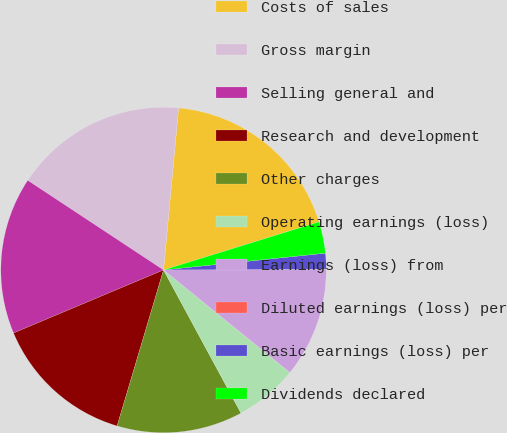Convert chart. <chart><loc_0><loc_0><loc_500><loc_500><pie_chart><fcel>Costs of sales<fcel>Gross margin<fcel>Selling general and<fcel>Research and development<fcel>Other charges<fcel>Operating earnings (loss)<fcel>Earnings (loss) from<fcel>Diluted earnings (loss) per<fcel>Basic earnings (loss) per<fcel>Dividends declared<nl><fcel>18.75%<fcel>17.19%<fcel>15.62%<fcel>14.06%<fcel>12.5%<fcel>6.25%<fcel>10.94%<fcel>0.0%<fcel>1.56%<fcel>3.13%<nl></chart> 